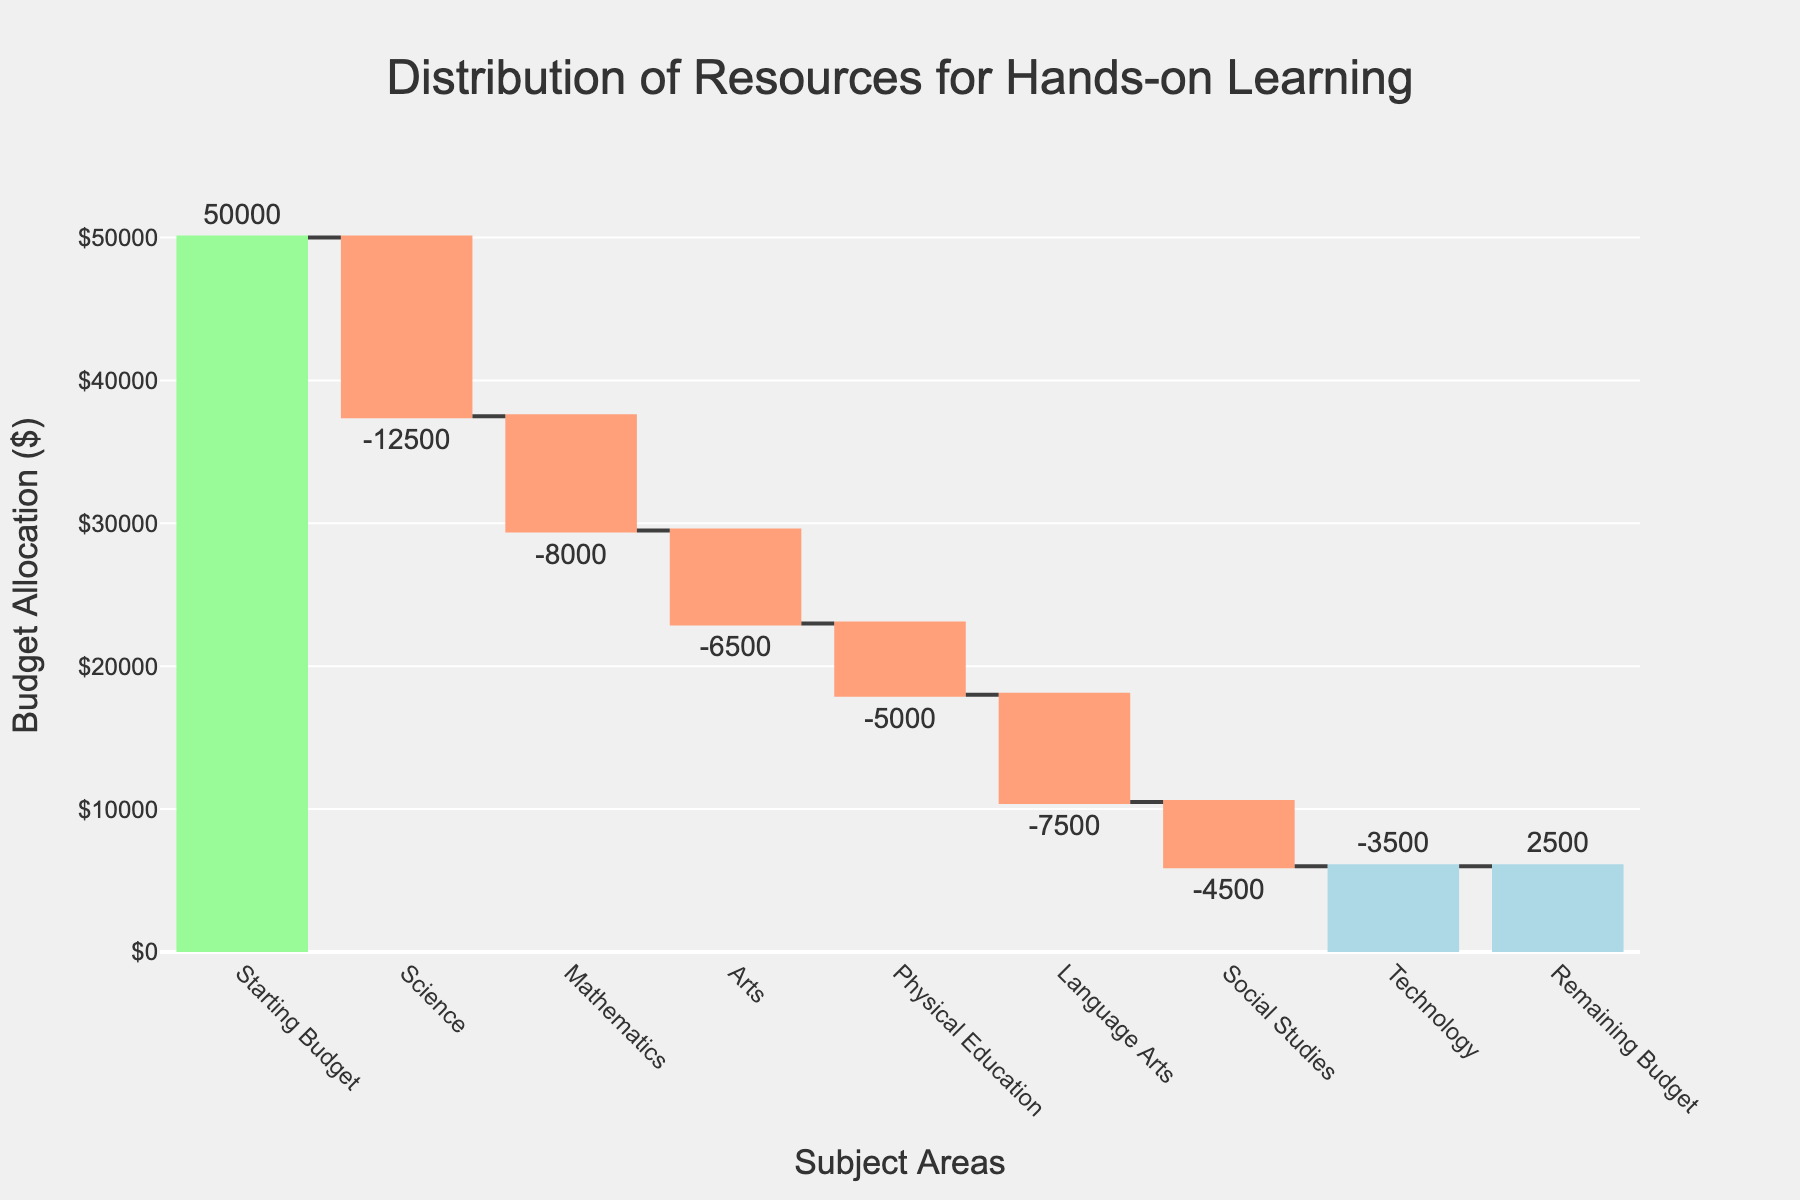What is the starting budget? The starting budget is depicted at the beginning of the waterfall chart under the "Starting Budget" label.
Answer: $50,000 Which subject area received the largest allocation of resources? By examining the chart, the largest negative value (bar extending downwards) represents the largest allocation of resources. The "Science" subject area shows the highest deduction of $12,500.
Answer: Science What is the remaining budget after all allocations? The "Remaining Budget" is explicitly mentioned at the end of the chart, showing the final amount remaining.
Answer: $2,500 How much funding was allocated to the three subjects with the smallest deductions combined? Identifying the three smallest deductions in the chart: Technology ($3,500), Social Studies ($4,500), and Physical Education ($5,000). Summing these figures: $3,500 + $4,500 + $5,000 = $13,000.
Answer: $13,000 Which subject area deducted the least amount of resources? By looking at the bars with the smallest downward extension, "Technology" has the smallest deduction of $3,500.
Answer: Technology How does the allocation for Mathematics compare to Language Arts? Comparing the heights of the bars for Mathematics and Language Arts, Mathematics shows a deduction of $8,000 while Language Arts shows $7,500.
Answer: Mathematics received $500 more funds than Language Arts What is the total amount allocated across all subjects? To find the total allocation, sum all the negative values: $12,500 (Science) + $8,000 (Mathematics) + $6,500 (Arts) + $5,000 (Physical Education) + $7,500 (Language Arts) + $4,500 (Social Studies) + $3,500 (Technology) = $47,500.
Answer: $47,500 How much more was allocated to Science than to Arts? The allocation for Science is $12,500 and for Arts is $6,500. The difference is $12,500 - $6,500 = $6,000.
Answer: $6,000 What is the total amount spent on Arts and Social Studies combined? Summing the amounts for Arts ($6,500) and Social Studies ($4,500) gives $6,500 + $4,500 = $11,000.
Answer: $11,000 What percentage of the initial budget remains after all allocations? To find the percentage, the remaining budget ($2,500) is divided by the starting budget ($50,000) and multiplied by 100: ($2,500 / $50,000) * 100 = 5%.
Answer: 5% 